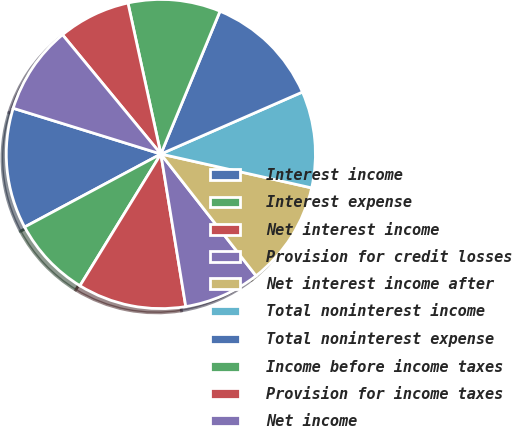Convert chart. <chart><loc_0><loc_0><loc_500><loc_500><pie_chart><fcel>Interest income<fcel>Interest expense<fcel>Net interest income<fcel>Provision for credit losses<fcel>Net interest income after<fcel>Total noninterest income<fcel>Total noninterest expense<fcel>Income before income taxes<fcel>Provision for income taxes<fcel>Net income<nl><fcel>12.61%<fcel>8.4%<fcel>11.34%<fcel>7.98%<fcel>10.92%<fcel>10.08%<fcel>12.18%<fcel>9.66%<fcel>7.56%<fcel>9.24%<nl></chart> 